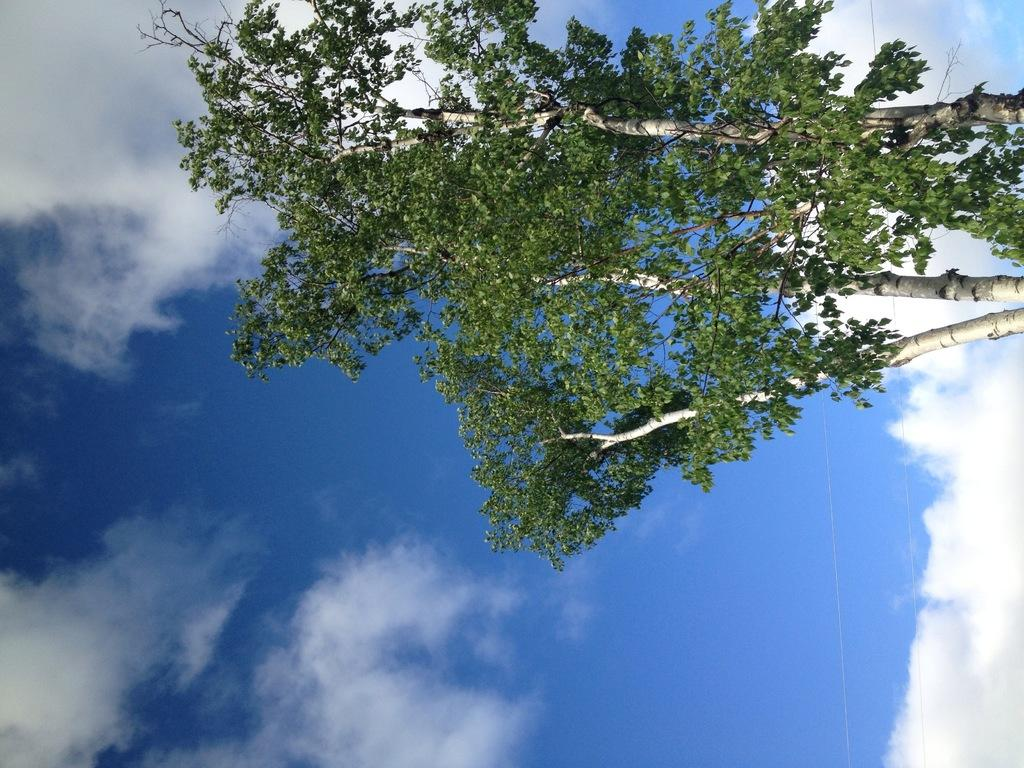What type of tree is present in the image? There is a green color tree in the image. What colors can be seen in the sky in the image? The sky is blue and white in color. How many fingers can be seen pointing at the tree in the image? There is no mention of fingers or pointing in the image, so it cannot be determined. 